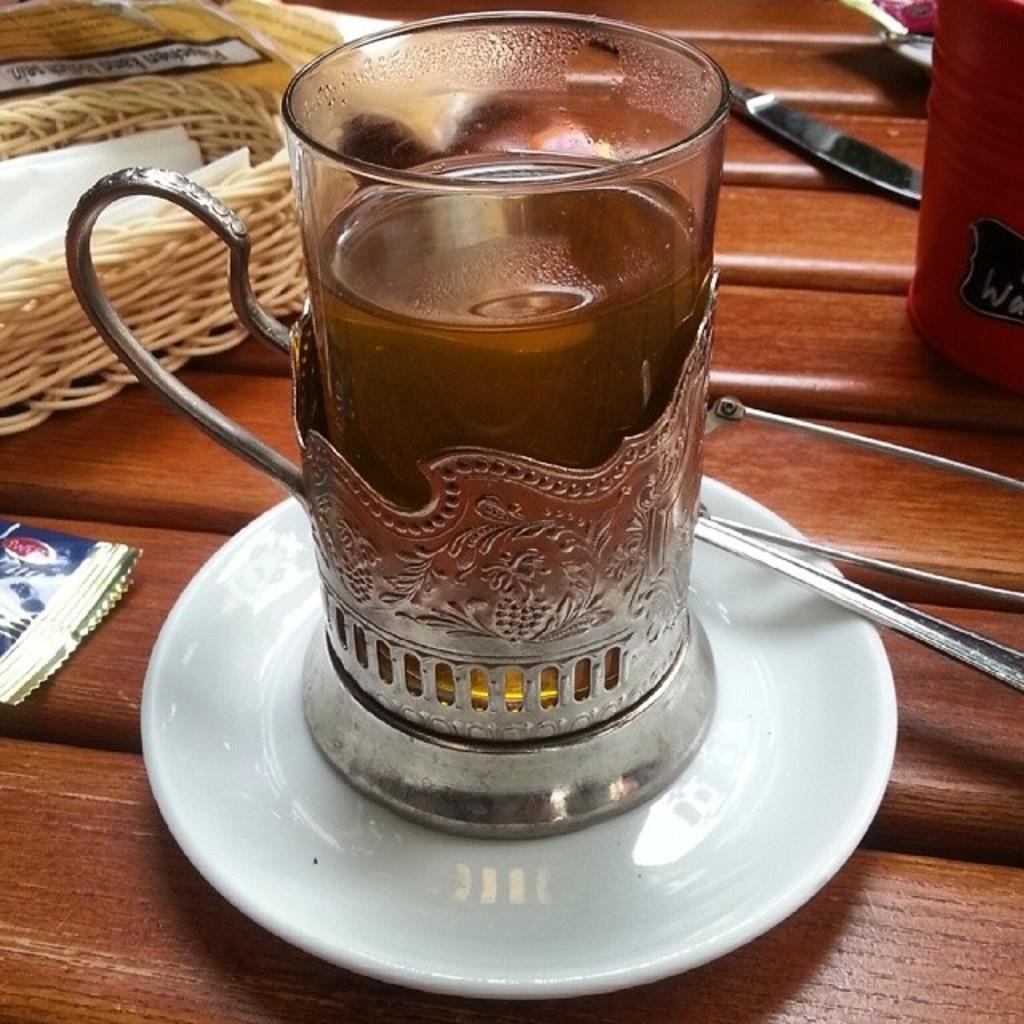Could you give a brief overview of what you see in this image? In this picture we can see glass with drink in it placed on saucer and aside to this we have knife, basket with tissues in it. 